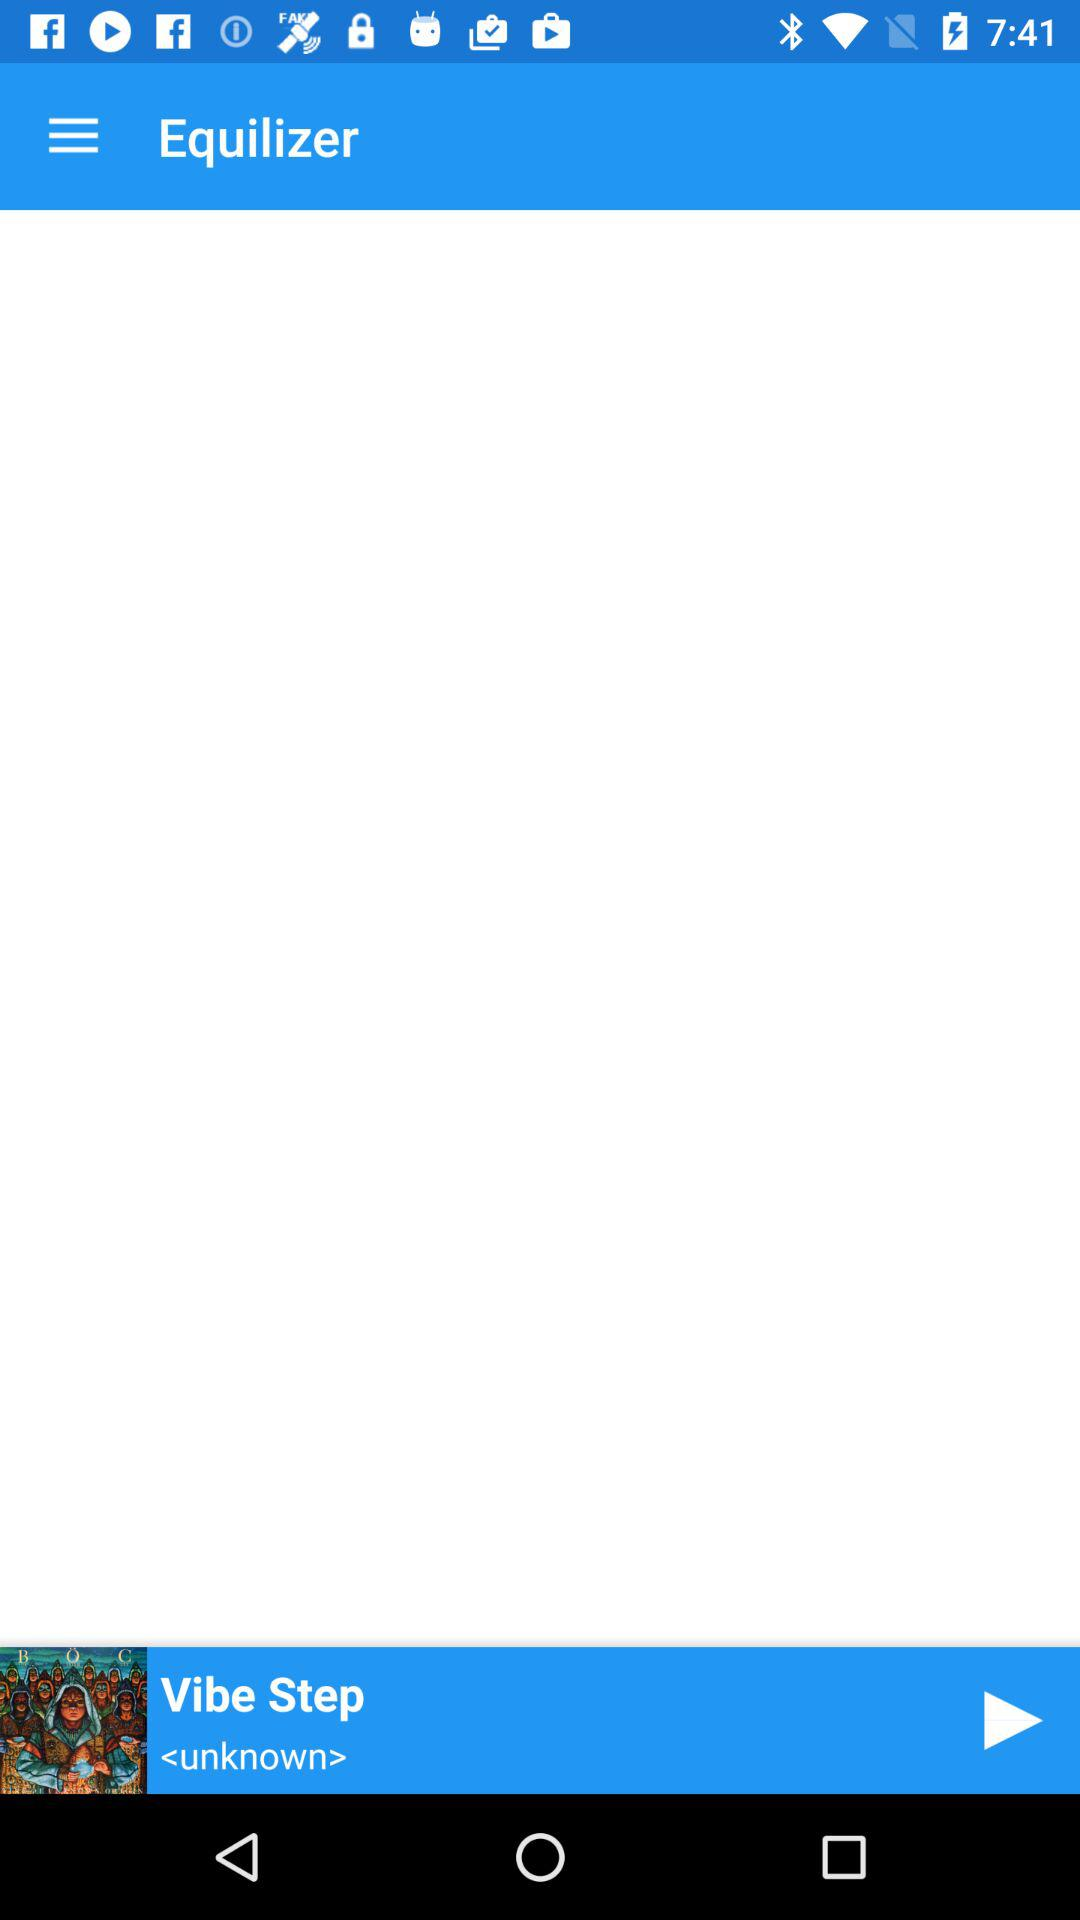What is the name of application? The name of the application is "Equilizer". 